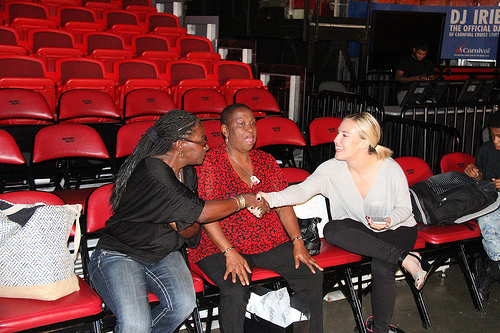<image>
Can you confirm if the human is on the other human? No. The human is not positioned on the other human. They may be near each other, but the human is not supported by or resting on top of the other human. Where is the purse in relation to the woman? Is it to the right of the woman? Yes. From this viewpoint, the purse is positioned to the right side relative to the woman. Where is the lisa in relation to the ann? Is it in front of the ann? Yes. The lisa is positioned in front of the ann, appearing closer to the camera viewpoint. 